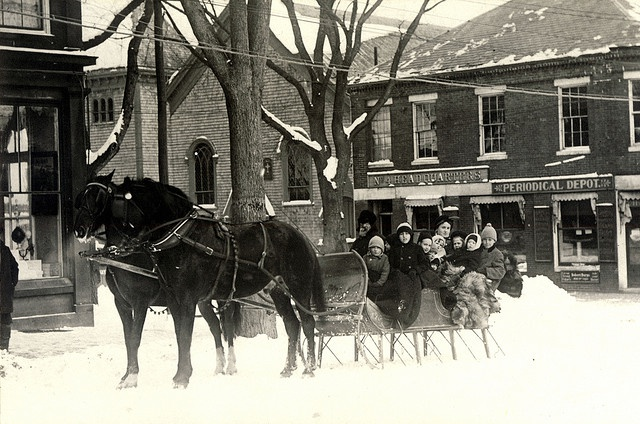Describe the objects in this image and their specific colors. I can see horse in gray, black, and darkgray tones, horse in gray, black, ivory, and darkgray tones, people in gray, black, and beige tones, people in gray, black, lightgray, and darkgray tones, and people in gray, black, and darkgray tones in this image. 